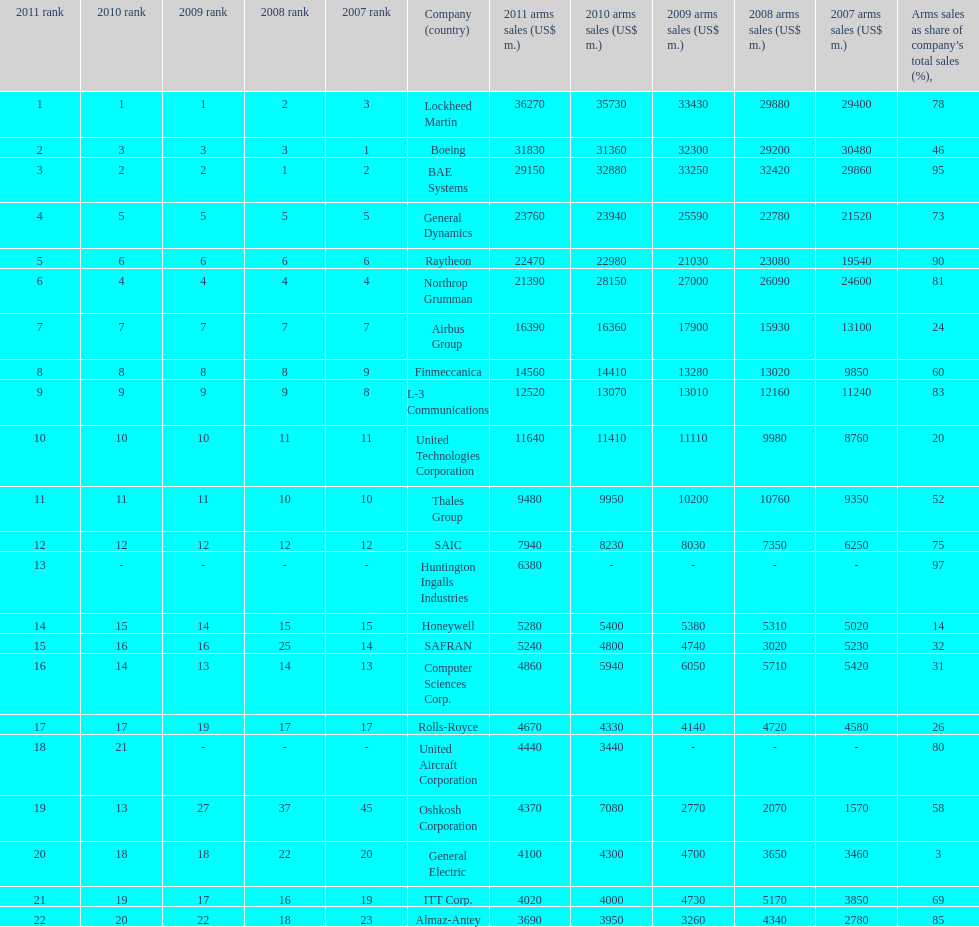What is the total number of countries mentioned? 6. 